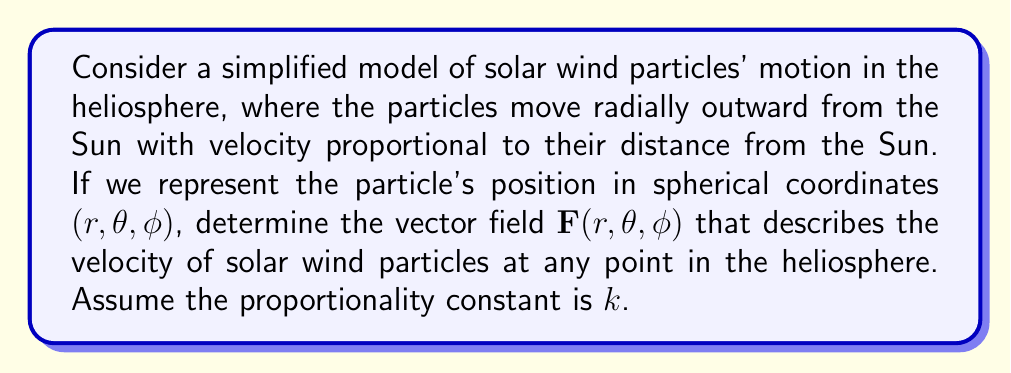What is the answer to this math problem? To determine the vector field representation of solar wind particles' motion in the heliosphere, we'll follow these steps:

1) In spherical coordinates, the position vector is given by:
   $$\mathbf{r} = r\hat{r} + \theta\hat{\theta} + \phi\hat{\phi}$$

2) The velocity vector will be in the radial direction (outward from the Sun) and proportional to $r$. Therefore, it will only have a component in the $\hat{r}$ direction:
   $$\mathbf{v} = kr\hat{r}$$
   where $k$ is the proportionality constant.

3) The vector field $\mathbf{F}(r, \theta, \phi)$ representing the velocity at any point is thus:
   $$\mathbf{F}(r, \theta, \phi) = kr\hat{r}$$

4) In terms of Cartesian unit vectors, we can express this as:
   $$\mathbf{F}(r, \theta, \phi) = kr(\sin\theta\cos\phi\hat{i} + \sin\theta\sin\phi\hat{j} + \cos\theta\hat{k})$$

5) This vector field is independent of $\theta$ and $\phi$ in its magnitude, but the direction changes based on the position in the heliosphere.

6) The magnitude of the vector field at any point is:
   $$|\mathbf{F}(r, \theta, \phi)| = kr$$

This vector field represents a radial outflow of particles from the Sun, with velocity increasing linearly with distance from the Sun, which is a simplified model of solar wind behavior in the heliosphere.
Answer: $\mathbf{F}(r, \theta, \phi) = kr\hat{r}$ 